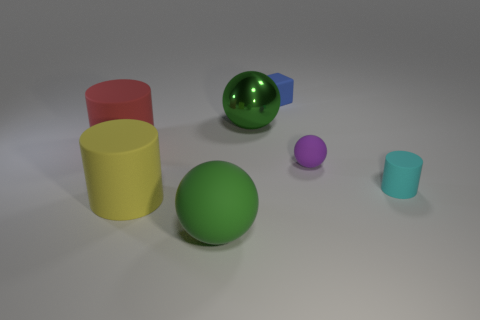Add 1 large red rubber objects. How many objects exist? 8 Subtract all cylinders. How many objects are left? 4 Subtract all large gray matte spheres. Subtract all tiny cyan rubber cylinders. How many objects are left? 6 Add 2 large metal balls. How many large metal balls are left? 3 Add 3 rubber spheres. How many rubber spheres exist? 5 Subtract 0 yellow cubes. How many objects are left? 7 